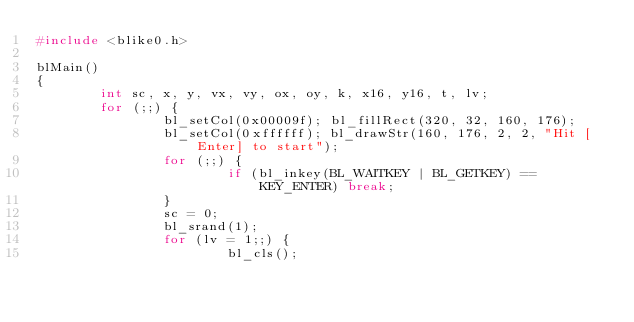Convert code to text. <code><loc_0><loc_0><loc_500><loc_500><_C_>#include <blike0.h>

blMain()
{
        int sc, x, y, vx, vy, ox, oy, k, x16, y16, t, lv;
        for (;;) {
                bl_setCol(0x00009f); bl_fillRect(320, 32, 160, 176);
                bl_setCol(0xffffff); bl_drawStr(160, 176, 2, 2, "Hit [Enter] to start");
                for (;;) {
                        if (bl_inkey(BL_WAITKEY | BL_GETKEY) == KEY_ENTER) break;
                }
                sc = 0;
                bl_srand(1);
                for (lv = 1;;) {
                        bl_cls();</code> 